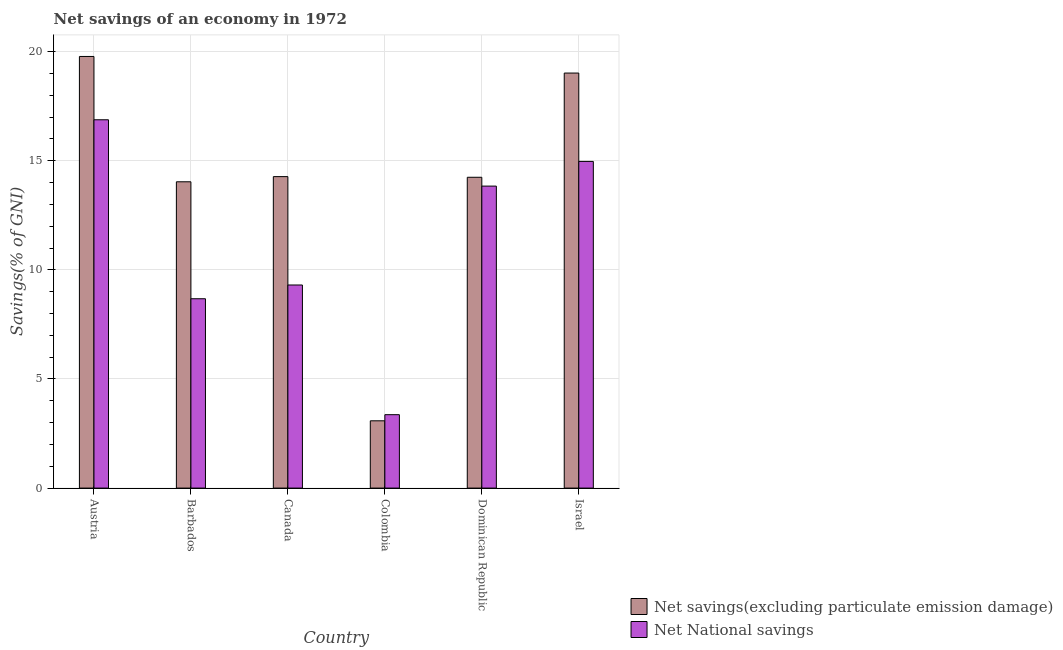How many different coloured bars are there?
Offer a very short reply. 2. Are the number of bars on each tick of the X-axis equal?
Offer a terse response. Yes. How many bars are there on the 2nd tick from the left?
Offer a terse response. 2. What is the label of the 2nd group of bars from the left?
Ensure brevity in your answer.  Barbados. What is the net savings(excluding particulate emission damage) in Colombia?
Offer a very short reply. 3.08. Across all countries, what is the maximum net savings(excluding particulate emission damage)?
Give a very brief answer. 19.78. Across all countries, what is the minimum net national savings?
Give a very brief answer. 3.36. In which country was the net savings(excluding particulate emission damage) maximum?
Your response must be concise. Austria. What is the total net savings(excluding particulate emission damage) in the graph?
Provide a short and direct response. 84.43. What is the difference between the net national savings in Canada and that in Dominican Republic?
Provide a short and direct response. -4.53. What is the difference between the net national savings in Canada and the net savings(excluding particulate emission damage) in Austria?
Ensure brevity in your answer.  -10.47. What is the average net savings(excluding particulate emission damage) per country?
Your response must be concise. 14.07. What is the difference between the net savings(excluding particulate emission damage) and net national savings in Barbados?
Provide a succinct answer. 5.36. In how many countries, is the net national savings greater than 5 %?
Make the answer very short. 5. What is the ratio of the net national savings in Austria to that in Dominican Republic?
Ensure brevity in your answer.  1.22. Is the difference between the net savings(excluding particulate emission damage) in Barbados and Israel greater than the difference between the net national savings in Barbados and Israel?
Provide a succinct answer. Yes. What is the difference between the highest and the second highest net savings(excluding particulate emission damage)?
Provide a short and direct response. 0.76. What is the difference between the highest and the lowest net savings(excluding particulate emission damage)?
Provide a succinct answer. 16.7. In how many countries, is the net national savings greater than the average net national savings taken over all countries?
Your answer should be compact. 3. Is the sum of the net savings(excluding particulate emission damage) in Colombia and Israel greater than the maximum net national savings across all countries?
Ensure brevity in your answer.  Yes. What does the 2nd bar from the left in Colombia represents?
Provide a short and direct response. Net National savings. What does the 1st bar from the right in Austria represents?
Your answer should be compact. Net National savings. How many bars are there?
Make the answer very short. 12. What is the difference between two consecutive major ticks on the Y-axis?
Provide a short and direct response. 5. Are the values on the major ticks of Y-axis written in scientific E-notation?
Keep it short and to the point. No. Does the graph contain grids?
Ensure brevity in your answer.  Yes. Where does the legend appear in the graph?
Your response must be concise. Bottom right. How many legend labels are there?
Make the answer very short. 2. How are the legend labels stacked?
Ensure brevity in your answer.  Vertical. What is the title of the graph?
Provide a short and direct response. Net savings of an economy in 1972. Does "Non-pregnant women" appear as one of the legend labels in the graph?
Make the answer very short. No. What is the label or title of the Y-axis?
Keep it short and to the point. Savings(% of GNI). What is the Savings(% of GNI) of Net savings(excluding particulate emission damage) in Austria?
Offer a very short reply. 19.78. What is the Savings(% of GNI) of Net National savings in Austria?
Provide a short and direct response. 16.88. What is the Savings(% of GNI) of Net savings(excluding particulate emission damage) in Barbados?
Offer a terse response. 14.04. What is the Savings(% of GNI) of Net National savings in Barbados?
Your response must be concise. 8.68. What is the Savings(% of GNI) of Net savings(excluding particulate emission damage) in Canada?
Provide a succinct answer. 14.27. What is the Savings(% of GNI) in Net National savings in Canada?
Your answer should be very brief. 9.31. What is the Savings(% of GNI) in Net savings(excluding particulate emission damage) in Colombia?
Offer a terse response. 3.08. What is the Savings(% of GNI) in Net National savings in Colombia?
Give a very brief answer. 3.36. What is the Savings(% of GNI) in Net savings(excluding particulate emission damage) in Dominican Republic?
Provide a succinct answer. 14.24. What is the Savings(% of GNI) in Net National savings in Dominican Republic?
Your response must be concise. 13.84. What is the Savings(% of GNI) of Net savings(excluding particulate emission damage) in Israel?
Your response must be concise. 19.02. What is the Savings(% of GNI) in Net National savings in Israel?
Give a very brief answer. 14.97. Across all countries, what is the maximum Savings(% of GNI) of Net savings(excluding particulate emission damage)?
Offer a very short reply. 19.78. Across all countries, what is the maximum Savings(% of GNI) in Net National savings?
Offer a terse response. 16.88. Across all countries, what is the minimum Savings(% of GNI) in Net savings(excluding particulate emission damage)?
Ensure brevity in your answer.  3.08. Across all countries, what is the minimum Savings(% of GNI) in Net National savings?
Make the answer very short. 3.36. What is the total Savings(% of GNI) in Net savings(excluding particulate emission damage) in the graph?
Give a very brief answer. 84.43. What is the total Savings(% of GNI) of Net National savings in the graph?
Your answer should be compact. 67.03. What is the difference between the Savings(% of GNI) in Net savings(excluding particulate emission damage) in Austria and that in Barbados?
Provide a succinct answer. 5.74. What is the difference between the Savings(% of GNI) in Net National savings in Austria and that in Barbados?
Offer a very short reply. 8.2. What is the difference between the Savings(% of GNI) of Net savings(excluding particulate emission damage) in Austria and that in Canada?
Make the answer very short. 5.51. What is the difference between the Savings(% of GNI) in Net National savings in Austria and that in Canada?
Offer a very short reply. 7.57. What is the difference between the Savings(% of GNI) of Net savings(excluding particulate emission damage) in Austria and that in Colombia?
Give a very brief answer. 16.7. What is the difference between the Savings(% of GNI) in Net National savings in Austria and that in Colombia?
Offer a terse response. 13.51. What is the difference between the Savings(% of GNI) of Net savings(excluding particulate emission damage) in Austria and that in Dominican Republic?
Provide a succinct answer. 5.54. What is the difference between the Savings(% of GNI) in Net National savings in Austria and that in Dominican Republic?
Offer a very short reply. 3.04. What is the difference between the Savings(% of GNI) in Net savings(excluding particulate emission damage) in Austria and that in Israel?
Make the answer very short. 0.76. What is the difference between the Savings(% of GNI) of Net National savings in Austria and that in Israel?
Give a very brief answer. 1.91. What is the difference between the Savings(% of GNI) in Net savings(excluding particulate emission damage) in Barbados and that in Canada?
Make the answer very short. -0.24. What is the difference between the Savings(% of GNI) in Net National savings in Barbados and that in Canada?
Offer a terse response. -0.63. What is the difference between the Savings(% of GNI) of Net savings(excluding particulate emission damage) in Barbados and that in Colombia?
Ensure brevity in your answer.  10.95. What is the difference between the Savings(% of GNI) in Net National savings in Barbados and that in Colombia?
Keep it short and to the point. 5.31. What is the difference between the Savings(% of GNI) in Net savings(excluding particulate emission damage) in Barbados and that in Dominican Republic?
Keep it short and to the point. -0.21. What is the difference between the Savings(% of GNI) in Net National savings in Barbados and that in Dominican Republic?
Give a very brief answer. -5.16. What is the difference between the Savings(% of GNI) in Net savings(excluding particulate emission damage) in Barbados and that in Israel?
Provide a succinct answer. -4.98. What is the difference between the Savings(% of GNI) in Net National savings in Barbados and that in Israel?
Ensure brevity in your answer.  -6.29. What is the difference between the Savings(% of GNI) of Net savings(excluding particulate emission damage) in Canada and that in Colombia?
Your answer should be very brief. 11.19. What is the difference between the Savings(% of GNI) in Net National savings in Canada and that in Colombia?
Give a very brief answer. 5.94. What is the difference between the Savings(% of GNI) of Net savings(excluding particulate emission damage) in Canada and that in Dominican Republic?
Ensure brevity in your answer.  0.03. What is the difference between the Savings(% of GNI) in Net National savings in Canada and that in Dominican Republic?
Make the answer very short. -4.53. What is the difference between the Savings(% of GNI) in Net savings(excluding particulate emission damage) in Canada and that in Israel?
Your answer should be compact. -4.75. What is the difference between the Savings(% of GNI) of Net National savings in Canada and that in Israel?
Make the answer very short. -5.66. What is the difference between the Savings(% of GNI) in Net savings(excluding particulate emission damage) in Colombia and that in Dominican Republic?
Offer a very short reply. -11.16. What is the difference between the Savings(% of GNI) of Net National savings in Colombia and that in Dominican Republic?
Ensure brevity in your answer.  -10.47. What is the difference between the Savings(% of GNI) in Net savings(excluding particulate emission damage) in Colombia and that in Israel?
Offer a terse response. -15.94. What is the difference between the Savings(% of GNI) of Net National savings in Colombia and that in Israel?
Your answer should be very brief. -11.61. What is the difference between the Savings(% of GNI) of Net savings(excluding particulate emission damage) in Dominican Republic and that in Israel?
Offer a very short reply. -4.78. What is the difference between the Savings(% of GNI) in Net National savings in Dominican Republic and that in Israel?
Make the answer very short. -1.13. What is the difference between the Savings(% of GNI) in Net savings(excluding particulate emission damage) in Austria and the Savings(% of GNI) in Net National savings in Barbados?
Give a very brief answer. 11.1. What is the difference between the Savings(% of GNI) of Net savings(excluding particulate emission damage) in Austria and the Savings(% of GNI) of Net National savings in Canada?
Keep it short and to the point. 10.47. What is the difference between the Savings(% of GNI) in Net savings(excluding particulate emission damage) in Austria and the Savings(% of GNI) in Net National savings in Colombia?
Give a very brief answer. 16.41. What is the difference between the Savings(% of GNI) of Net savings(excluding particulate emission damage) in Austria and the Savings(% of GNI) of Net National savings in Dominican Republic?
Provide a succinct answer. 5.94. What is the difference between the Savings(% of GNI) in Net savings(excluding particulate emission damage) in Austria and the Savings(% of GNI) in Net National savings in Israel?
Offer a very short reply. 4.81. What is the difference between the Savings(% of GNI) of Net savings(excluding particulate emission damage) in Barbados and the Savings(% of GNI) of Net National savings in Canada?
Make the answer very short. 4.73. What is the difference between the Savings(% of GNI) in Net savings(excluding particulate emission damage) in Barbados and the Savings(% of GNI) in Net National savings in Colombia?
Ensure brevity in your answer.  10.67. What is the difference between the Savings(% of GNI) of Net savings(excluding particulate emission damage) in Barbados and the Savings(% of GNI) of Net National savings in Dominican Republic?
Ensure brevity in your answer.  0.2. What is the difference between the Savings(% of GNI) in Net savings(excluding particulate emission damage) in Barbados and the Savings(% of GNI) in Net National savings in Israel?
Offer a very short reply. -0.93. What is the difference between the Savings(% of GNI) of Net savings(excluding particulate emission damage) in Canada and the Savings(% of GNI) of Net National savings in Colombia?
Keep it short and to the point. 10.91. What is the difference between the Savings(% of GNI) in Net savings(excluding particulate emission damage) in Canada and the Savings(% of GNI) in Net National savings in Dominican Republic?
Offer a very short reply. 0.43. What is the difference between the Savings(% of GNI) of Net savings(excluding particulate emission damage) in Canada and the Savings(% of GNI) of Net National savings in Israel?
Your answer should be compact. -0.7. What is the difference between the Savings(% of GNI) of Net savings(excluding particulate emission damage) in Colombia and the Savings(% of GNI) of Net National savings in Dominican Republic?
Provide a short and direct response. -10.76. What is the difference between the Savings(% of GNI) in Net savings(excluding particulate emission damage) in Colombia and the Savings(% of GNI) in Net National savings in Israel?
Offer a terse response. -11.89. What is the difference between the Savings(% of GNI) in Net savings(excluding particulate emission damage) in Dominican Republic and the Savings(% of GNI) in Net National savings in Israel?
Your answer should be compact. -0.73. What is the average Savings(% of GNI) in Net savings(excluding particulate emission damage) per country?
Your answer should be very brief. 14.07. What is the average Savings(% of GNI) of Net National savings per country?
Ensure brevity in your answer.  11.17. What is the difference between the Savings(% of GNI) of Net savings(excluding particulate emission damage) and Savings(% of GNI) of Net National savings in Austria?
Offer a very short reply. 2.9. What is the difference between the Savings(% of GNI) in Net savings(excluding particulate emission damage) and Savings(% of GNI) in Net National savings in Barbados?
Your response must be concise. 5.36. What is the difference between the Savings(% of GNI) of Net savings(excluding particulate emission damage) and Savings(% of GNI) of Net National savings in Canada?
Your answer should be compact. 4.97. What is the difference between the Savings(% of GNI) in Net savings(excluding particulate emission damage) and Savings(% of GNI) in Net National savings in Colombia?
Your answer should be very brief. -0.28. What is the difference between the Savings(% of GNI) in Net savings(excluding particulate emission damage) and Savings(% of GNI) in Net National savings in Dominican Republic?
Ensure brevity in your answer.  0.4. What is the difference between the Savings(% of GNI) in Net savings(excluding particulate emission damage) and Savings(% of GNI) in Net National savings in Israel?
Provide a succinct answer. 4.05. What is the ratio of the Savings(% of GNI) in Net savings(excluding particulate emission damage) in Austria to that in Barbados?
Keep it short and to the point. 1.41. What is the ratio of the Savings(% of GNI) in Net National savings in Austria to that in Barbados?
Ensure brevity in your answer.  1.95. What is the ratio of the Savings(% of GNI) in Net savings(excluding particulate emission damage) in Austria to that in Canada?
Keep it short and to the point. 1.39. What is the ratio of the Savings(% of GNI) in Net National savings in Austria to that in Canada?
Ensure brevity in your answer.  1.81. What is the ratio of the Savings(% of GNI) of Net savings(excluding particulate emission damage) in Austria to that in Colombia?
Your answer should be compact. 6.42. What is the ratio of the Savings(% of GNI) of Net National savings in Austria to that in Colombia?
Offer a very short reply. 5.02. What is the ratio of the Savings(% of GNI) of Net savings(excluding particulate emission damage) in Austria to that in Dominican Republic?
Provide a succinct answer. 1.39. What is the ratio of the Savings(% of GNI) of Net National savings in Austria to that in Dominican Republic?
Make the answer very short. 1.22. What is the ratio of the Savings(% of GNI) in Net National savings in Austria to that in Israel?
Give a very brief answer. 1.13. What is the ratio of the Savings(% of GNI) in Net savings(excluding particulate emission damage) in Barbados to that in Canada?
Keep it short and to the point. 0.98. What is the ratio of the Savings(% of GNI) of Net National savings in Barbados to that in Canada?
Your response must be concise. 0.93. What is the ratio of the Savings(% of GNI) in Net savings(excluding particulate emission damage) in Barbados to that in Colombia?
Provide a succinct answer. 4.55. What is the ratio of the Savings(% of GNI) in Net National savings in Barbados to that in Colombia?
Your answer should be very brief. 2.58. What is the ratio of the Savings(% of GNI) of Net savings(excluding particulate emission damage) in Barbados to that in Dominican Republic?
Your answer should be compact. 0.99. What is the ratio of the Savings(% of GNI) of Net National savings in Barbados to that in Dominican Republic?
Provide a succinct answer. 0.63. What is the ratio of the Savings(% of GNI) of Net savings(excluding particulate emission damage) in Barbados to that in Israel?
Make the answer very short. 0.74. What is the ratio of the Savings(% of GNI) of Net National savings in Barbados to that in Israel?
Provide a succinct answer. 0.58. What is the ratio of the Savings(% of GNI) in Net savings(excluding particulate emission damage) in Canada to that in Colombia?
Offer a very short reply. 4.63. What is the ratio of the Savings(% of GNI) of Net National savings in Canada to that in Colombia?
Provide a succinct answer. 2.77. What is the ratio of the Savings(% of GNI) of Net savings(excluding particulate emission damage) in Canada to that in Dominican Republic?
Keep it short and to the point. 1. What is the ratio of the Savings(% of GNI) in Net National savings in Canada to that in Dominican Republic?
Provide a short and direct response. 0.67. What is the ratio of the Savings(% of GNI) in Net savings(excluding particulate emission damage) in Canada to that in Israel?
Your answer should be very brief. 0.75. What is the ratio of the Savings(% of GNI) in Net National savings in Canada to that in Israel?
Offer a very short reply. 0.62. What is the ratio of the Savings(% of GNI) of Net savings(excluding particulate emission damage) in Colombia to that in Dominican Republic?
Your answer should be very brief. 0.22. What is the ratio of the Savings(% of GNI) of Net National savings in Colombia to that in Dominican Republic?
Provide a short and direct response. 0.24. What is the ratio of the Savings(% of GNI) in Net savings(excluding particulate emission damage) in Colombia to that in Israel?
Provide a succinct answer. 0.16. What is the ratio of the Savings(% of GNI) in Net National savings in Colombia to that in Israel?
Your answer should be very brief. 0.22. What is the ratio of the Savings(% of GNI) in Net savings(excluding particulate emission damage) in Dominican Republic to that in Israel?
Provide a succinct answer. 0.75. What is the ratio of the Savings(% of GNI) of Net National savings in Dominican Republic to that in Israel?
Your answer should be very brief. 0.92. What is the difference between the highest and the second highest Savings(% of GNI) of Net savings(excluding particulate emission damage)?
Offer a terse response. 0.76. What is the difference between the highest and the second highest Savings(% of GNI) in Net National savings?
Provide a succinct answer. 1.91. What is the difference between the highest and the lowest Savings(% of GNI) in Net savings(excluding particulate emission damage)?
Provide a succinct answer. 16.7. What is the difference between the highest and the lowest Savings(% of GNI) in Net National savings?
Offer a terse response. 13.51. 